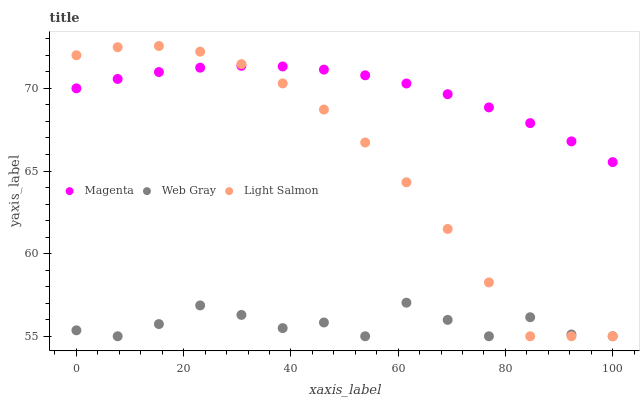Does Web Gray have the minimum area under the curve?
Answer yes or no. Yes. Does Magenta have the maximum area under the curve?
Answer yes or no. Yes. Does Light Salmon have the minimum area under the curve?
Answer yes or no. No. Does Light Salmon have the maximum area under the curve?
Answer yes or no. No. Is Magenta the smoothest?
Answer yes or no. Yes. Is Web Gray the roughest?
Answer yes or no. Yes. Is Light Salmon the smoothest?
Answer yes or no. No. Is Light Salmon the roughest?
Answer yes or no. No. Does Web Gray have the lowest value?
Answer yes or no. Yes. Does Light Salmon have the highest value?
Answer yes or no. Yes. Does Web Gray have the highest value?
Answer yes or no. No. Is Web Gray less than Magenta?
Answer yes or no. Yes. Is Magenta greater than Web Gray?
Answer yes or no. Yes. Does Web Gray intersect Light Salmon?
Answer yes or no. Yes. Is Web Gray less than Light Salmon?
Answer yes or no. No. Is Web Gray greater than Light Salmon?
Answer yes or no. No. Does Web Gray intersect Magenta?
Answer yes or no. No. 